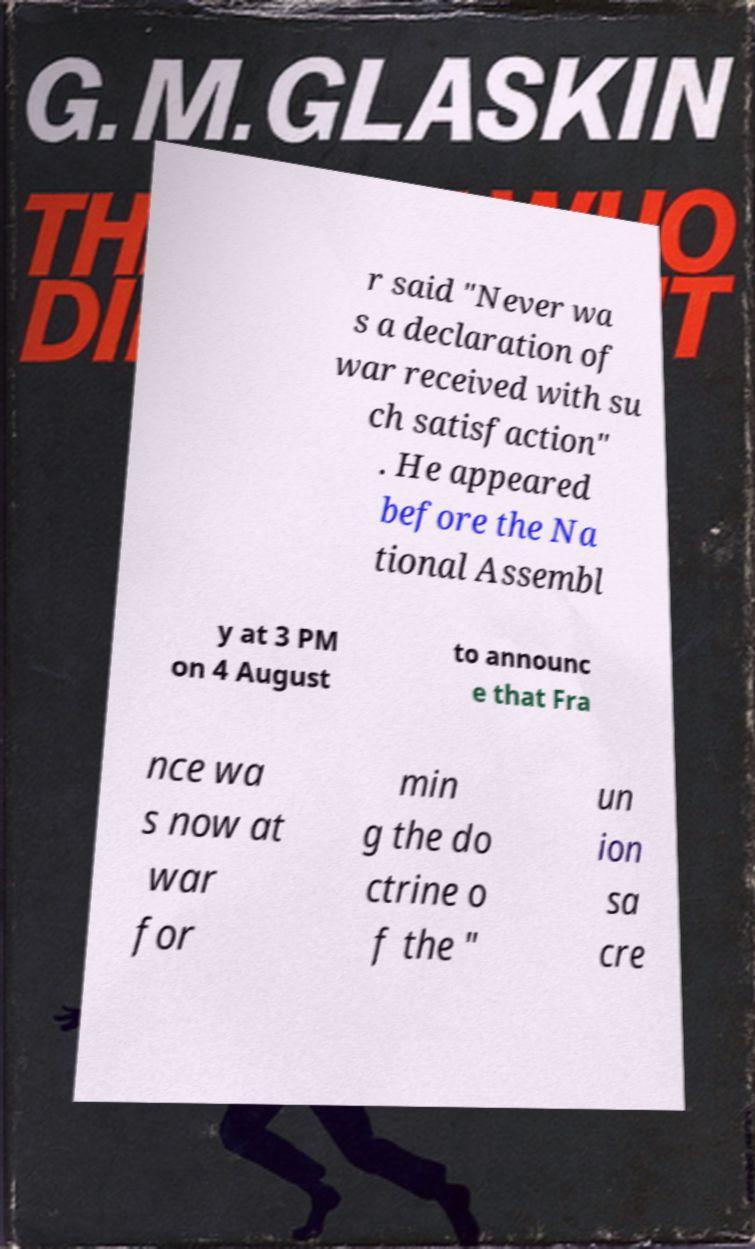Can you accurately transcribe the text from the provided image for me? r said "Never wa s a declaration of war received with su ch satisfaction" . He appeared before the Na tional Assembl y at 3 PM on 4 August to announc e that Fra nce wa s now at war for min g the do ctrine o f the " un ion sa cre 